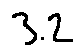<formula> <loc_0><loc_0><loc_500><loc_500>3 . 2</formula> 